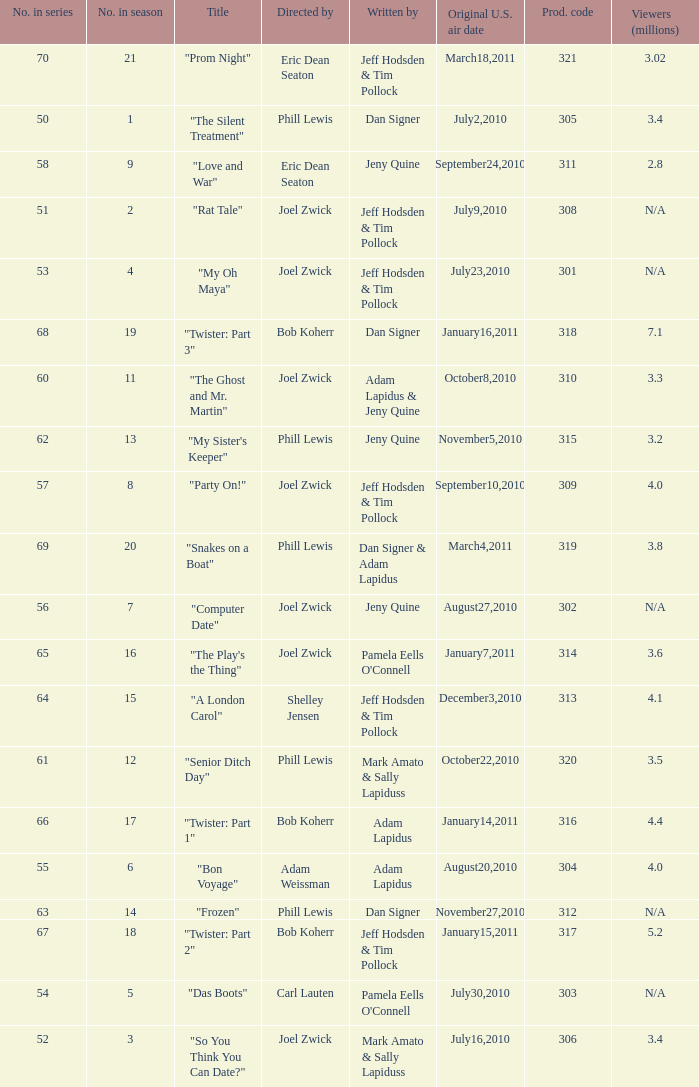Which US air date had 4.4 million viewers? January14,2011. 